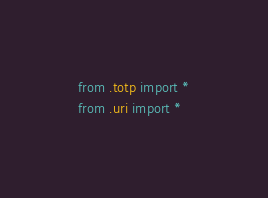<code> <loc_0><loc_0><loc_500><loc_500><_Python_>from .totp import *
from .uri import *
</code> 